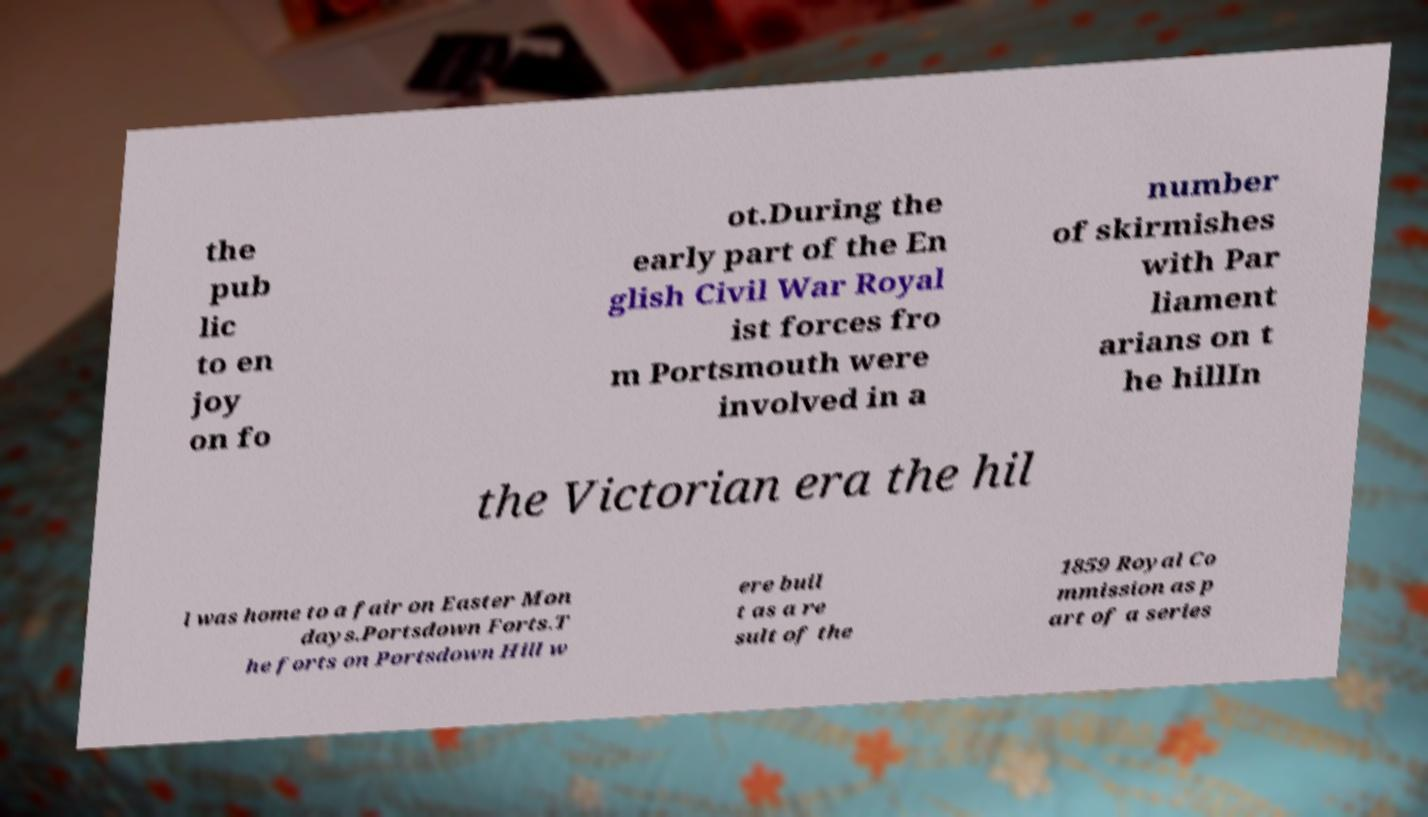Please identify and transcribe the text found in this image. the pub lic to en joy on fo ot.During the early part of the En glish Civil War Royal ist forces fro m Portsmouth were involved in a number of skirmishes with Par liament arians on t he hillIn the Victorian era the hil l was home to a fair on Easter Mon days.Portsdown Forts.T he forts on Portsdown Hill w ere buil t as a re sult of the 1859 Royal Co mmission as p art of a series 